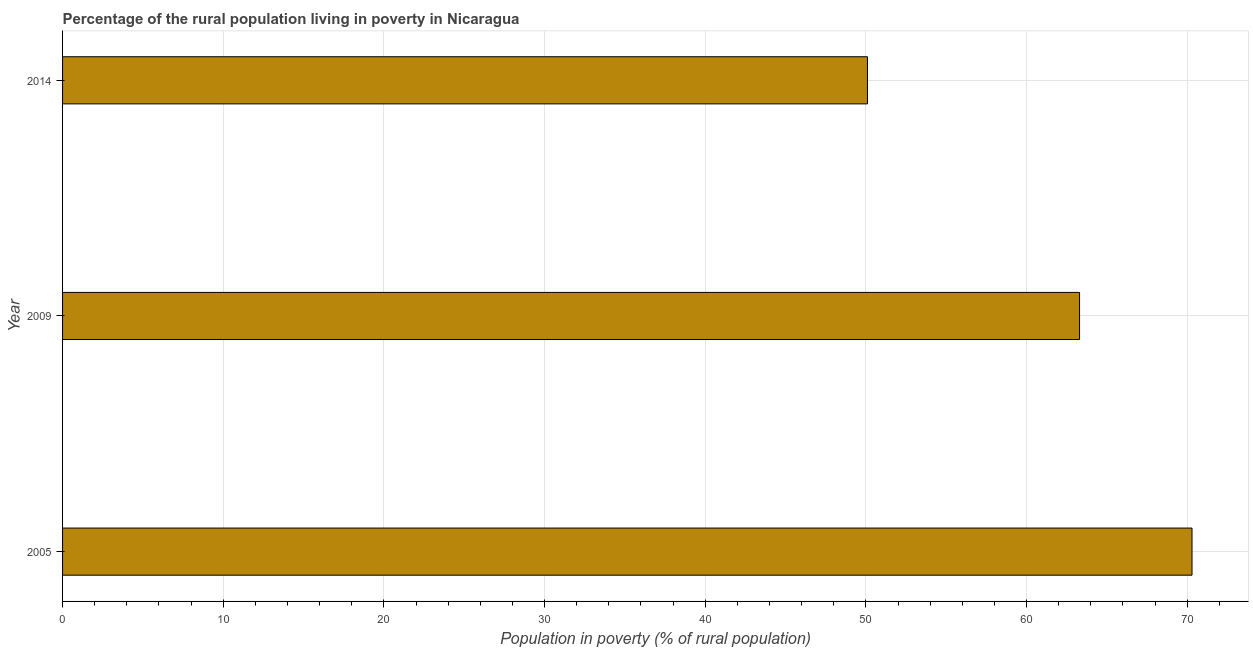What is the title of the graph?
Your response must be concise. Percentage of the rural population living in poverty in Nicaragua. What is the label or title of the X-axis?
Give a very brief answer. Population in poverty (% of rural population). What is the label or title of the Y-axis?
Give a very brief answer. Year. What is the percentage of rural population living below poverty line in 2005?
Offer a very short reply. 70.3. Across all years, what is the maximum percentage of rural population living below poverty line?
Your response must be concise. 70.3. Across all years, what is the minimum percentage of rural population living below poverty line?
Offer a terse response. 50.1. In which year was the percentage of rural population living below poverty line minimum?
Provide a succinct answer. 2014. What is the sum of the percentage of rural population living below poverty line?
Provide a succinct answer. 183.7. What is the difference between the percentage of rural population living below poverty line in 2005 and 2014?
Your response must be concise. 20.2. What is the average percentage of rural population living below poverty line per year?
Give a very brief answer. 61.23. What is the median percentage of rural population living below poverty line?
Your response must be concise. 63.3. Do a majority of the years between 2014 and 2009 (inclusive) have percentage of rural population living below poverty line greater than 70 %?
Your response must be concise. No. What is the ratio of the percentage of rural population living below poverty line in 2005 to that in 2014?
Provide a short and direct response. 1.4. What is the difference between the highest and the second highest percentage of rural population living below poverty line?
Your response must be concise. 7. Is the sum of the percentage of rural population living below poverty line in 2005 and 2009 greater than the maximum percentage of rural population living below poverty line across all years?
Your answer should be compact. Yes. What is the difference between the highest and the lowest percentage of rural population living below poverty line?
Ensure brevity in your answer.  20.2. In how many years, is the percentage of rural population living below poverty line greater than the average percentage of rural population living below poverty line taken over all years?
Give a very brief answer. 2. How many years are there in the graph?
Give a very brief answer. 3. What is the difference between two consecutive major ticks on the X-axis?
Ensure brevity in your answer.  10. What is the Population in poverty (% of rural population) of 2005?
Offer a terse response. 70.3. What is the Population in poverty (% of rural population) in 2009?
Provide a short and direct response. 63.3. What is the Population in poverty (% of rural population) of 2014?
Ensure brevity in your answer.  50.1. What is the difference between the Population in poverty (% of rural population) in 2005 and 2009?
Ensure brevity in your answer.  7. What is the difference between the Population in poverty (% of rural population) in 2005 and 2014?
Make the answer very short. 20.2. What is the difference between the Population in poverty (% of rural population) in 2009 and 2014?
Offer a very short reply. 13.2. What is the ratio of the Population in poverty (% of rural population) in 2005 to that in 2009?
Provide a succinct answer. 1.11. What is the ratio of the Population in poverty (% of rural population) in 2005 to that in 2014?
Keep it short and to the point. 1.4. What is the ratio of the Population in poverty (% of rural population) in 2009 to that in 2014?
Provide a short and direct response. 1.26. 